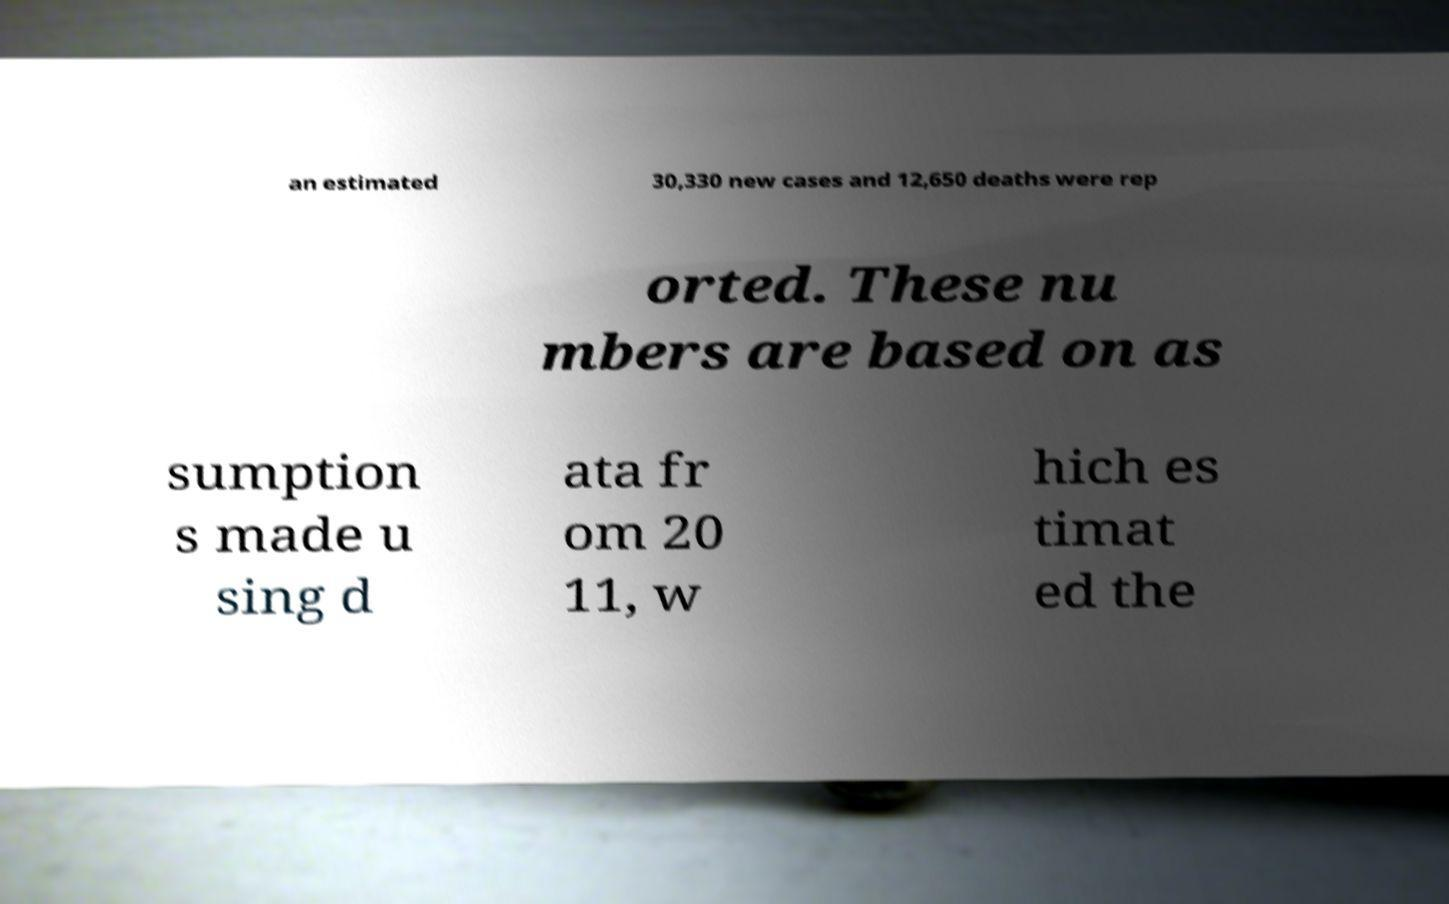Can you accurately transcribe the text from the provided image for me? an estimated 30,330 new cases and 12,650 deaths were rep orted. These nu mbers are based on as sumption s made u sing d ata fr om 20 11, w hich es timat ed the 